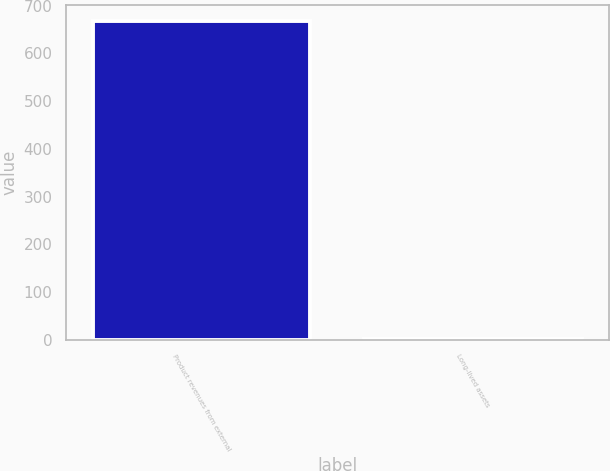Convert chart to OTSL. <chart><loc_0><loc_0><loc_500><loc_500><bar_chart><fcel>Product revenues from external<fcel>Long-lived assets<nl><fcel>668.1<fcel>2.3<nl></chart> 